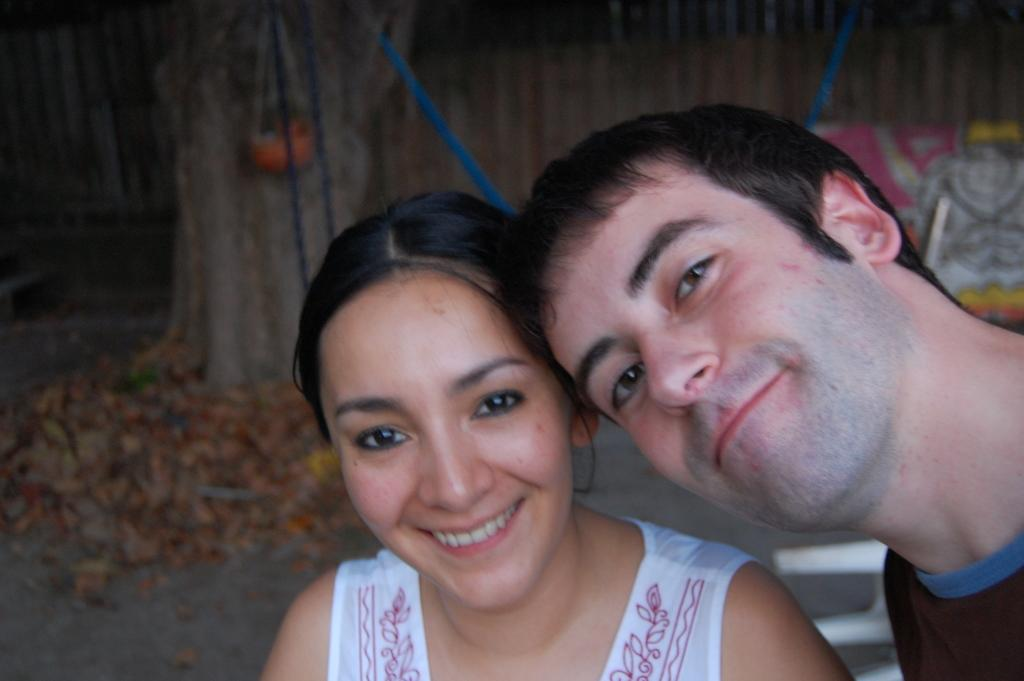How many people are in the image? There is a man and a woman in the image. What can be seen in the background of the image? The background of the image is blurred. What type of religion is being practiced by the tramp in the image? There is no tramp present in the image, and therefore no religious practice can be observed. 